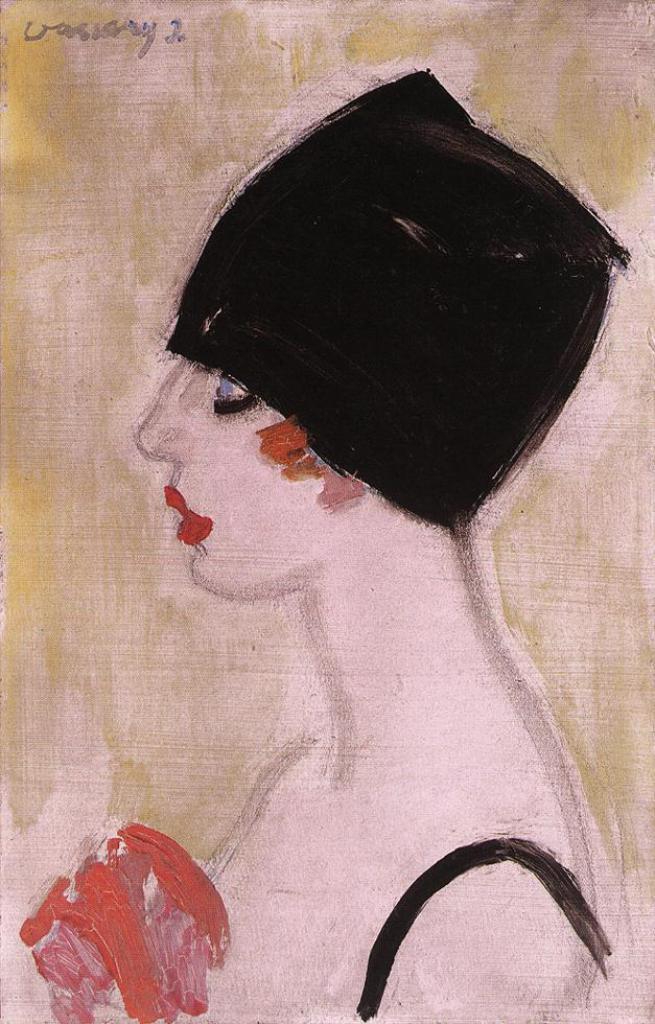Describe this image in one or two sentences. In this image we can see the painting of a woman. We can also see the text. 